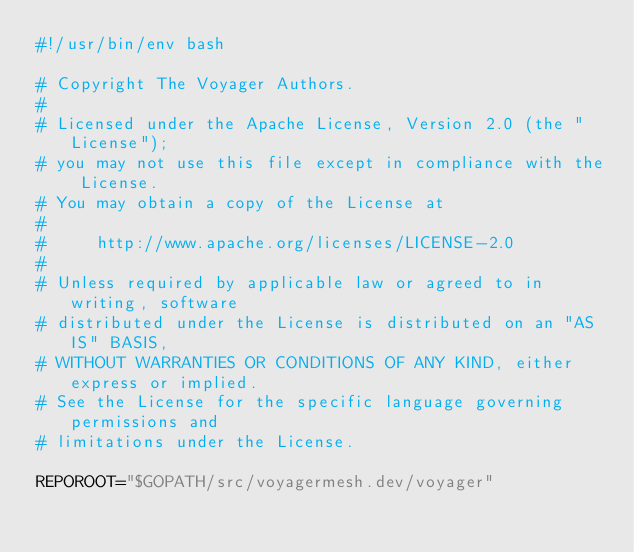Convert code to text. <code><loc_0><loc_0><loc_500><loc_500><_Bash_>#!/usr/bin/env bash

# Copyright The Voyager Authors.
#
# Licensed under the Apache License, Version 2.0 (the "License");
# you may not use this file except in compliance with the License.
# You may obtain a copy of the License at
#
#     http://www.apache.org/licenses/LICENSE-2.0
#
# Unless required by applicable law or agreed to in writing, software
# distributed under the License is distributed on an "AS IS" BASIS,
# WITHOUT WARRANTIES OR CONDITIONS OF ANY KIND, either express or implied.
# See the License for the specific language governing permissions and
# limitations under the License.

REPOROOT="$GOPATH/src/voyagermesh.dev/voyager"
</code> 